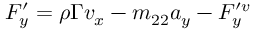<formula> <loc_0><loc_0><loc_500><loc_500>\begin{array} { r } { F _ { y } ^ { \prime } = \rho \Gamma v _ { x } - m _ { 2 2 } a _ { y } - F _ { y } ^ { \prime v } } \end{array}</formula> 